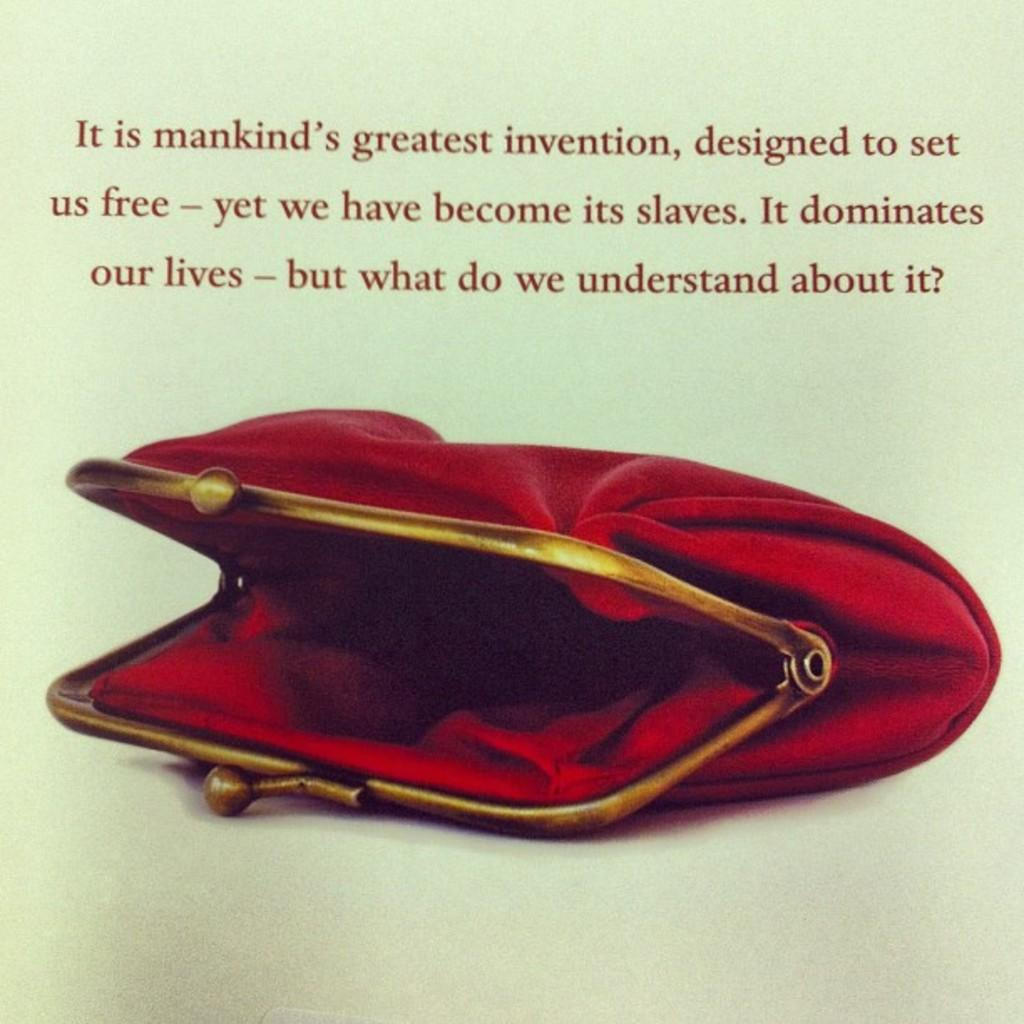What color is the bag that is visible in the image? There is a red color bag in the image. What else can be seen on the bag besides its color? There is some text on the bag. What type of account is associated with the branch shown on the bag? There is no branch or account mentioned or depicted on the bag in the image. 